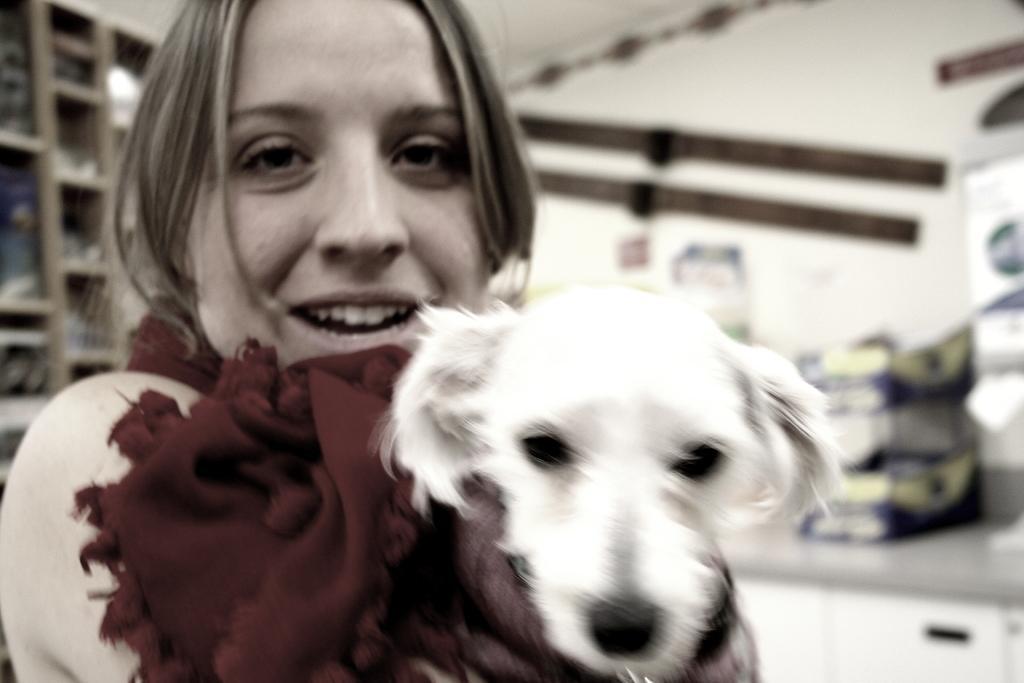In one or two sentences, can you explain what this image depicts? In this picture we can see woman smiling holding dog and in background we can see racks, wall and it is blurry. 